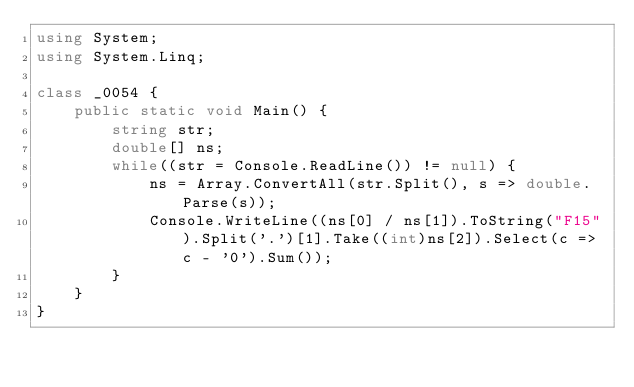<code> <loc_0><loc_0><loc_500><loc_500><_C#_>using System;
using System.Linq;

class _0054 {
    public static void Main() {
        string str;
        double[] ns;
        while((str = Console.ReadLine()) != null) {
            ns = Array.ConvertAll(str.Split(), s => double.Parse(s));
            Console.WriteLine((ns[0] / ns[1]).ToString("F15").Split('.')[1].Take((int)ns[2]).Select(c => c - '0').Sum());
        }
    }
}</code> 